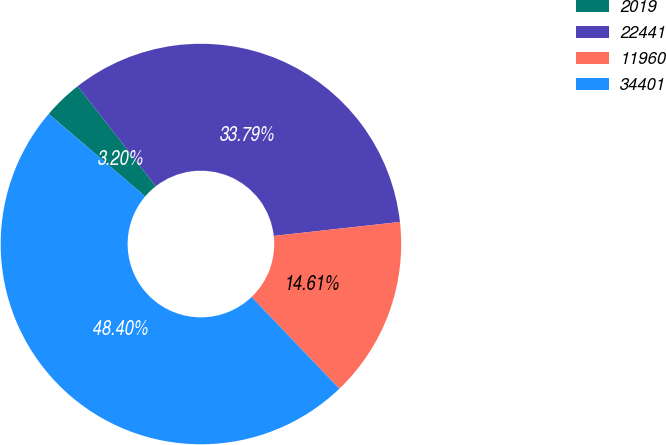Convert chart to OTSL. <chart><loc_0><loc_0><loc_500><loc_500><pie_chart><fcel>2019<fcel>22441<fcel>11960<fcel>34401<nl><fcel>3.2%<fcel>33.79%<fcel>14.61%<fcel>48.4%<nl></chart> 